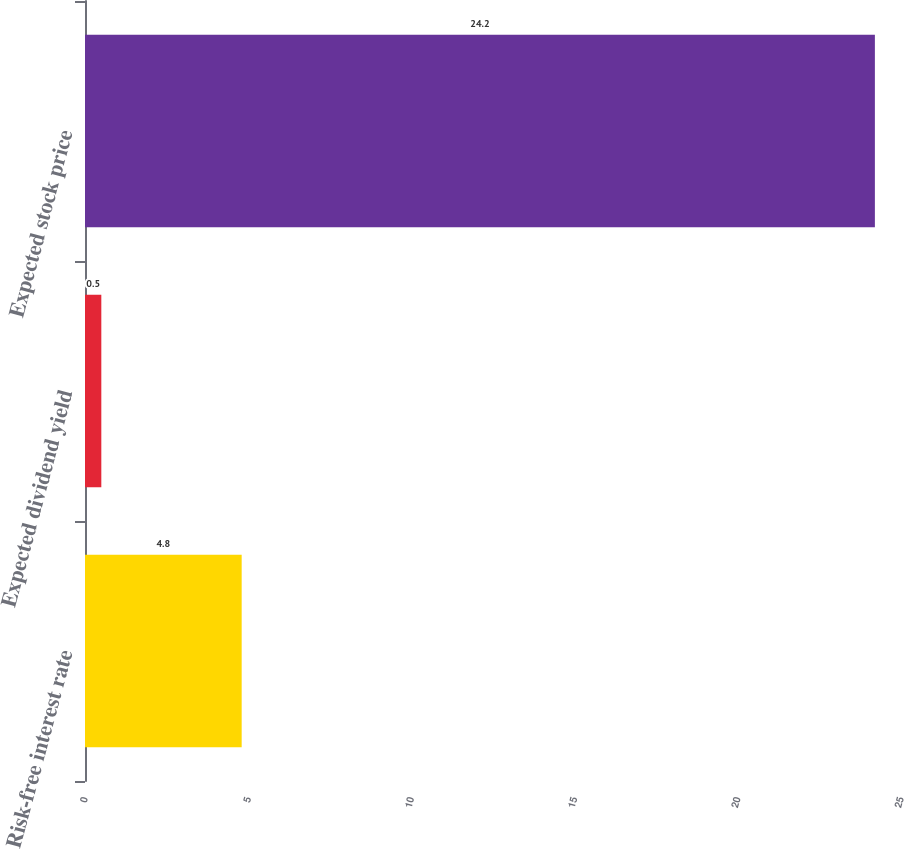<chart> <loc_0><loc_0><loc_500><loc_500><bar_chart><fcel>Risk-free interest rate<fcel>Expected dividend yield<fcel>Expected stock price<nl><fcel>4.8<fcel>0.5<fcel>24.2<nl></chart> 